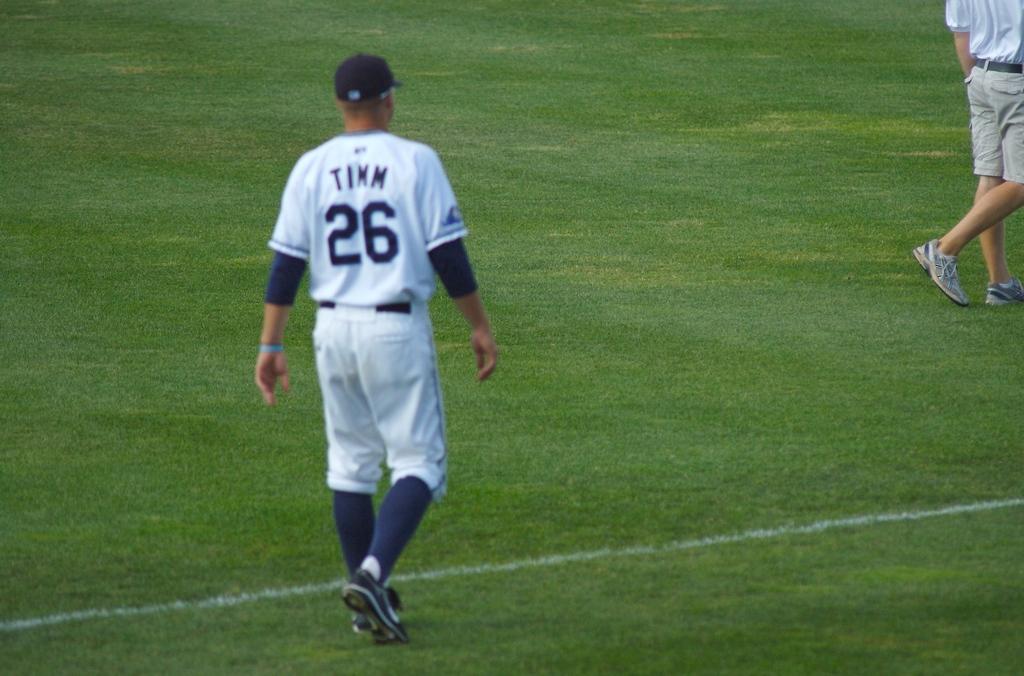What is the player's number?
Your answer should be very brief. 26. 